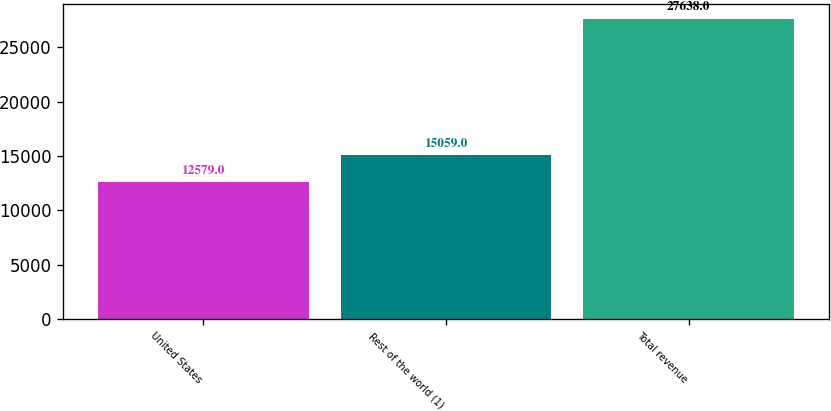<chart> <loc_0><loc_0><loc_500><loc_500><bar_chart><fcel>United States<fcel>Rest of the world (1)<fcel>Total revenue<nl><fcel>12579<fcel>15059<fcel>27638<nl></chart> 